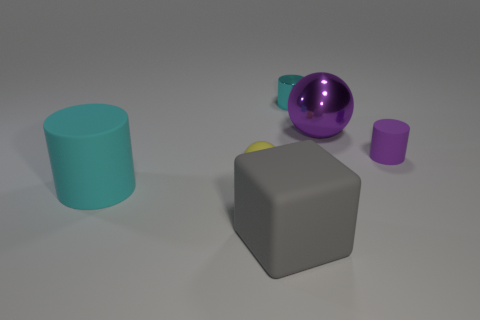Add 1 large cyan cylinders. How many objects exist? 7 Subtract all blocks. How many objects are left? 5 Subtract all purple things. Subtract all gray things. How many objects are left? 3 Add 1 gray rubber cubes. How many gray rubber cubes are left? 2 Add 3 tiny purple cylinders. How many tiny purple cylinders exist? 4 Subtract 0 cyan blocks. How many objects are left? 6 